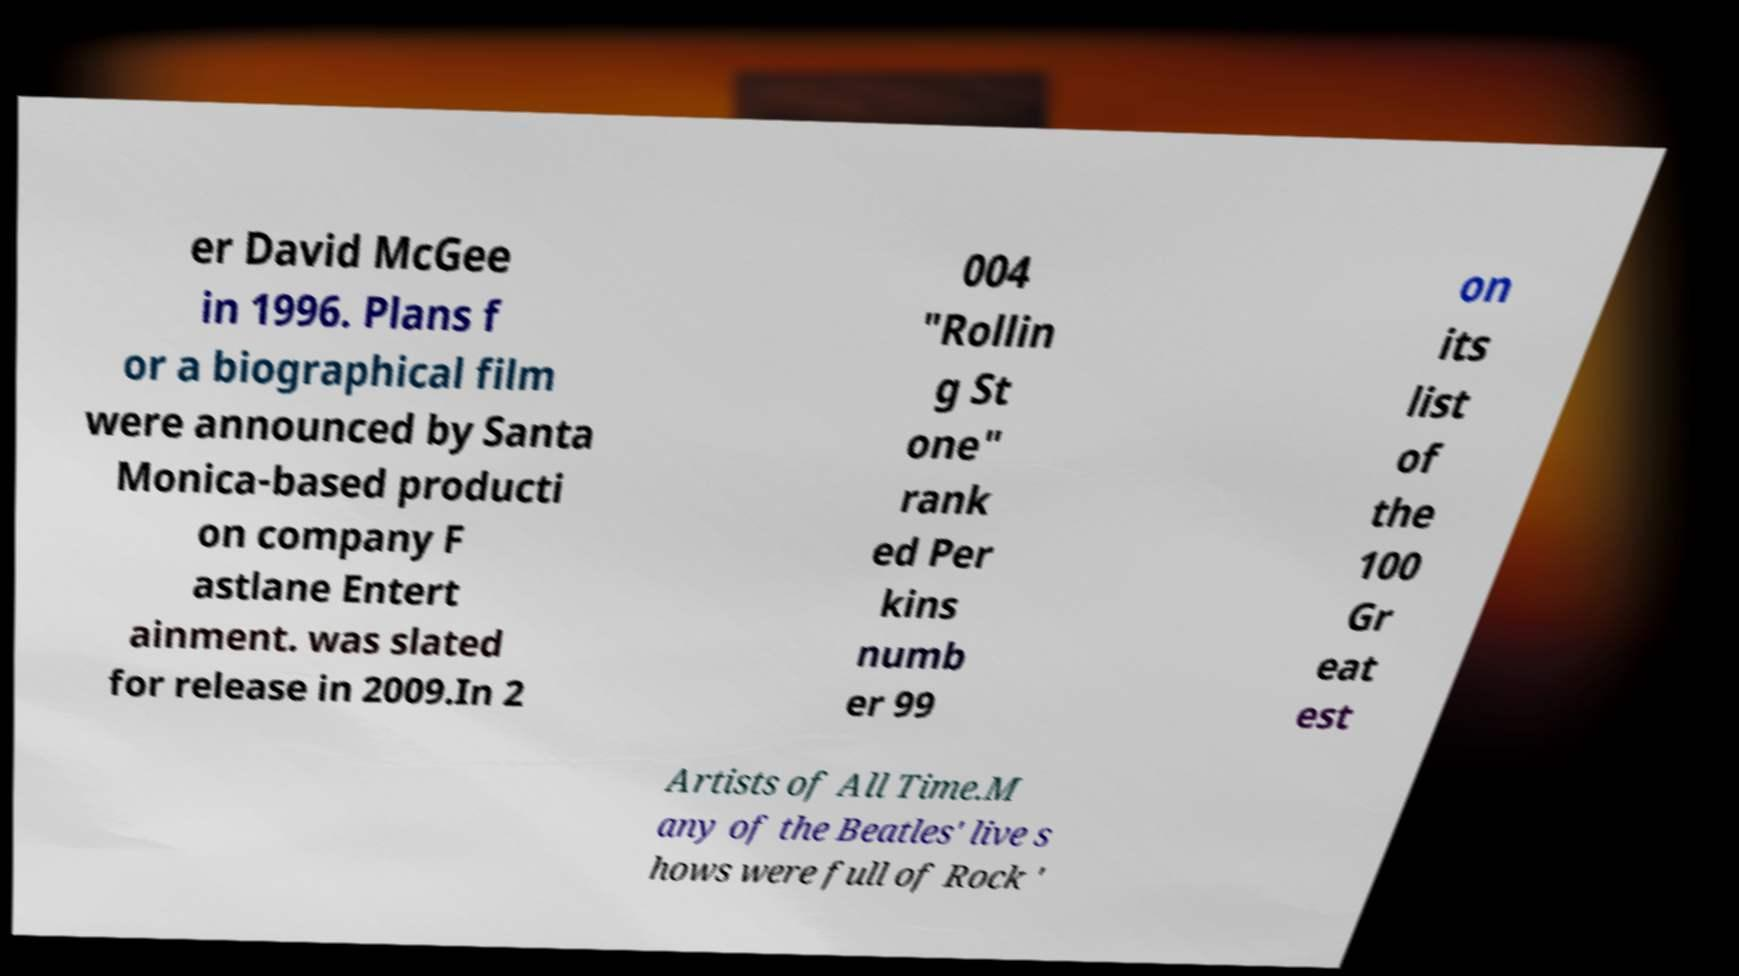Please identify and transcribe the text found in this image. er David McGee in 1996. Plans f or a biographical film were announced by Santa Monica-based producti on company F astlane Entert ainment. was slated for release in 2009.In 2 004 "Rollin g St one" rank ed Per kins numb er 99 on its list of the 100 Gr eat est Artists of All Time.M any of the Beatles' live s hows were full of Rock ' 